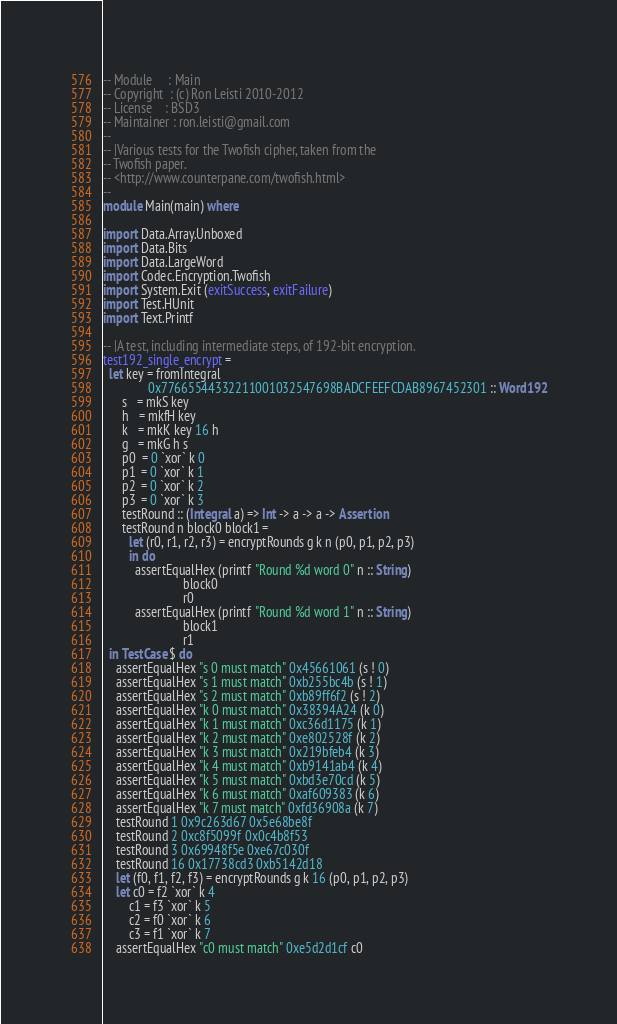Convert code to text. <code><loc_0><loc_0><loc_500><loc_500><_Haskell_>-- Module     : Main
-- Copyright  : (c) Ron Leisti 2010-2012
-- License    : BSD3
-- Maintainer : ron.leisti@gmail.com
--
-- |Various tests for the Twofish cipher, taken from the
-- Twofish paper.
-- <http://www.counterpane.com/twofish.html>
--
module Main(main) where

import Data.Array.Unboxed
import Data.Bits
import Data.LargeWord
import Codec.Encryption.Twofish
import System.Exit (exitSuccess, exitFailure)
import Test.HUnit
import Text.Printf

-- |A test, including intermediate steps, of 192-bit encryption.
test192_single_encrypt =
  let key = fromIntegral
              0x77665544332211001032547698BADCFEEFCDAB8967452301 :: Word192
      s   = mkS key
      h   = mkfH key
      k   = mkK key 16 h
      g   = mkG h s
      p0  = 0 `xor` k 0
      p1  = 0 `xor` k 1
      p2  = 0 `xor` k 2
      p3  = 0 `xor` k 3
      testRound :: (Integral a) => Int -> a -> a -> Assertion
      testRound n block0 block1 =
        let (r0, r1, r2, r3) = encryptRounds g k n (p0, p1, p2, p3)
        in do
          assertEqualHex (printf "Round %d word 0" n :: String)
                         block0
                         r0
          assertEqualHex (printf "Round %d word 1" n :: String)
                         block1
                         r1
  in TestCase $ do
    assertEqualHex "s 0 must match" 0x45661061 (s ! 0)
    assertEqualHex "s 1 must match" 0xb255bc4b (s ! 1)
    assertEqualHex "s 2 must match" 0xb89ff6f2 (s ! 2)
    assertEqualHex "k 0 must match" 0x38394A24 (k 0)
    assertEqualHex "k 1 must match" 0xc36d1175 (k 1)
    assertEqualHex "k 2 must match" 0xe802528f (k 2)
    assertEqualHex "k 3 must match" 0x219bfeb4 (k 3)
    assertEqualHex "k 4 must match" 0xb9141ab4 (k 4)
    assertEqualHex "k 5 must match" 0xbd3e70cd (k 5)
    assertEqualHex "k 6 must match" 0xaf609383 (k 6)
    assertEqualHex "k 7 must match" 0xfd36908a (k 7)
    testRound 1 0x9c263d67 0x5e68be8f
    testRound 2 0xc8f5099f 0x0c4b8f53
    testRound 3 0x69948f5e 0xe67c030f
    testRound 16 0x17738cd3 0xb5142d18
    let (f0, f1, f2, f3) = encryptRounds g k 16 (p0, p1, p2, p3)
    let c0 = f2 `xor` k 4
        c1 = f3 `xor` k 5
        c2 = f0 `xor` k 6
        c3 = f1 `xor` k 7
    assertEqualHex "c0 must match" 0xe5d2d1cf c0</code> 